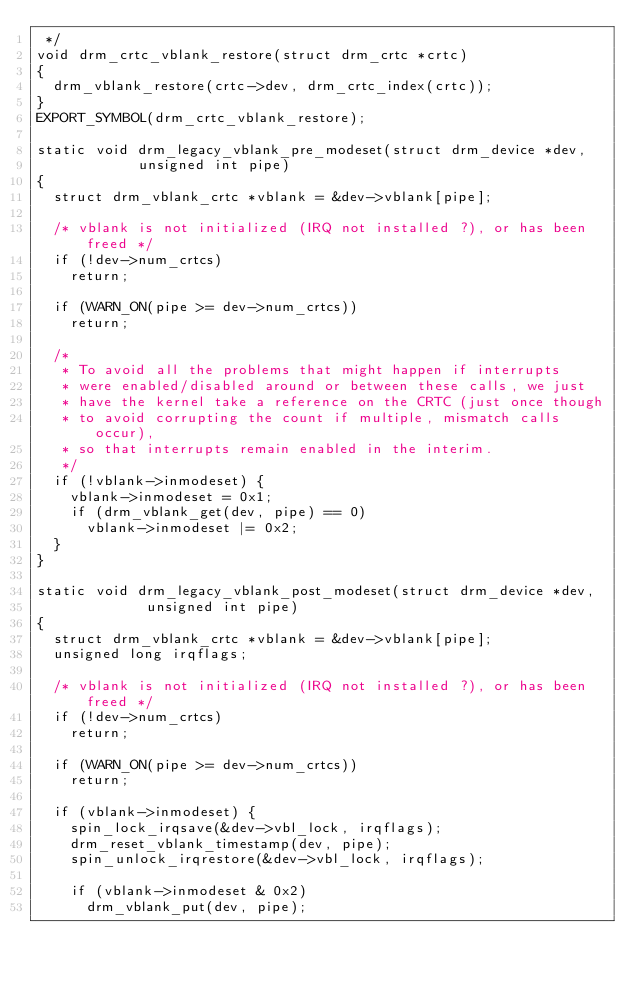<code> <loc_0><loc_0><loc_500><loc_500><_C_> */
void drm_crtc_vblank_restore(struct drm_crtc *crtc)
{
	drm_vblank_restore(crtc->dev, drm_crtc_index(crtc));
}
EXPORT_SYMBOL(drm_crtc_vblank_restore);

static void drm_legacy_vblank_pre_modeset(struct drm_device *dev,
					  unsigned int pipe)
{
	struct drm_vblank_crtc *vblank = &dev->vblank[pipe];

	/* vblank is not initialized (IRQ not installed ?), or has been freed */
	if (!dev->num_crtcs)
		return;

	if (WARN_ON(pipe >= dev->num_crtcs))
		return;

	/*
	 * To avoid all the problems that might happen if interrupts
	 * were enabled/disabled around or between these calls, we just
	 * have the kernel take a reference on the CRTC (just once though
	 * to avoid corrupting the count if multiple, mismatch calls occur),
	 * so that interrupts remain enabled in the interim.
	 */
	if (!vblank->inmodeset) {
		vblank->inmodeset = 0x1;
		if (drm_vblank_get(dev, pipe) == 0)
			vblank->inmodeset |= 0x2;
	}
}

static void drm_legacy_vblank_post_modeset(struct drm_device *dev,
					   unsigned int pipe)
{
	struct drm_vblank_crtc *vblank = &dev->vblank[pipe];
	unsigned long irqflags;

	/* vblank is not initialized (IRQ not installed ?), or has been freed */
	if (!dev->num_crtcs)
		return;

	if (WARN_ON(pipe >= dev->num_crtcs))
		return;

	if (vblank->inmodeset) {
		spin_lock_irqsave(&dev->vbl_lock, irqflags);
		drm_reset_vblank_timestamp(dev, pipe);
		spin_unlock_irqrestore(&dev->vbl_lock, irqflags);

		if (vblank->inmodeset & 0x2)
			drm_vblank_put(dev, pipe);
</code> 